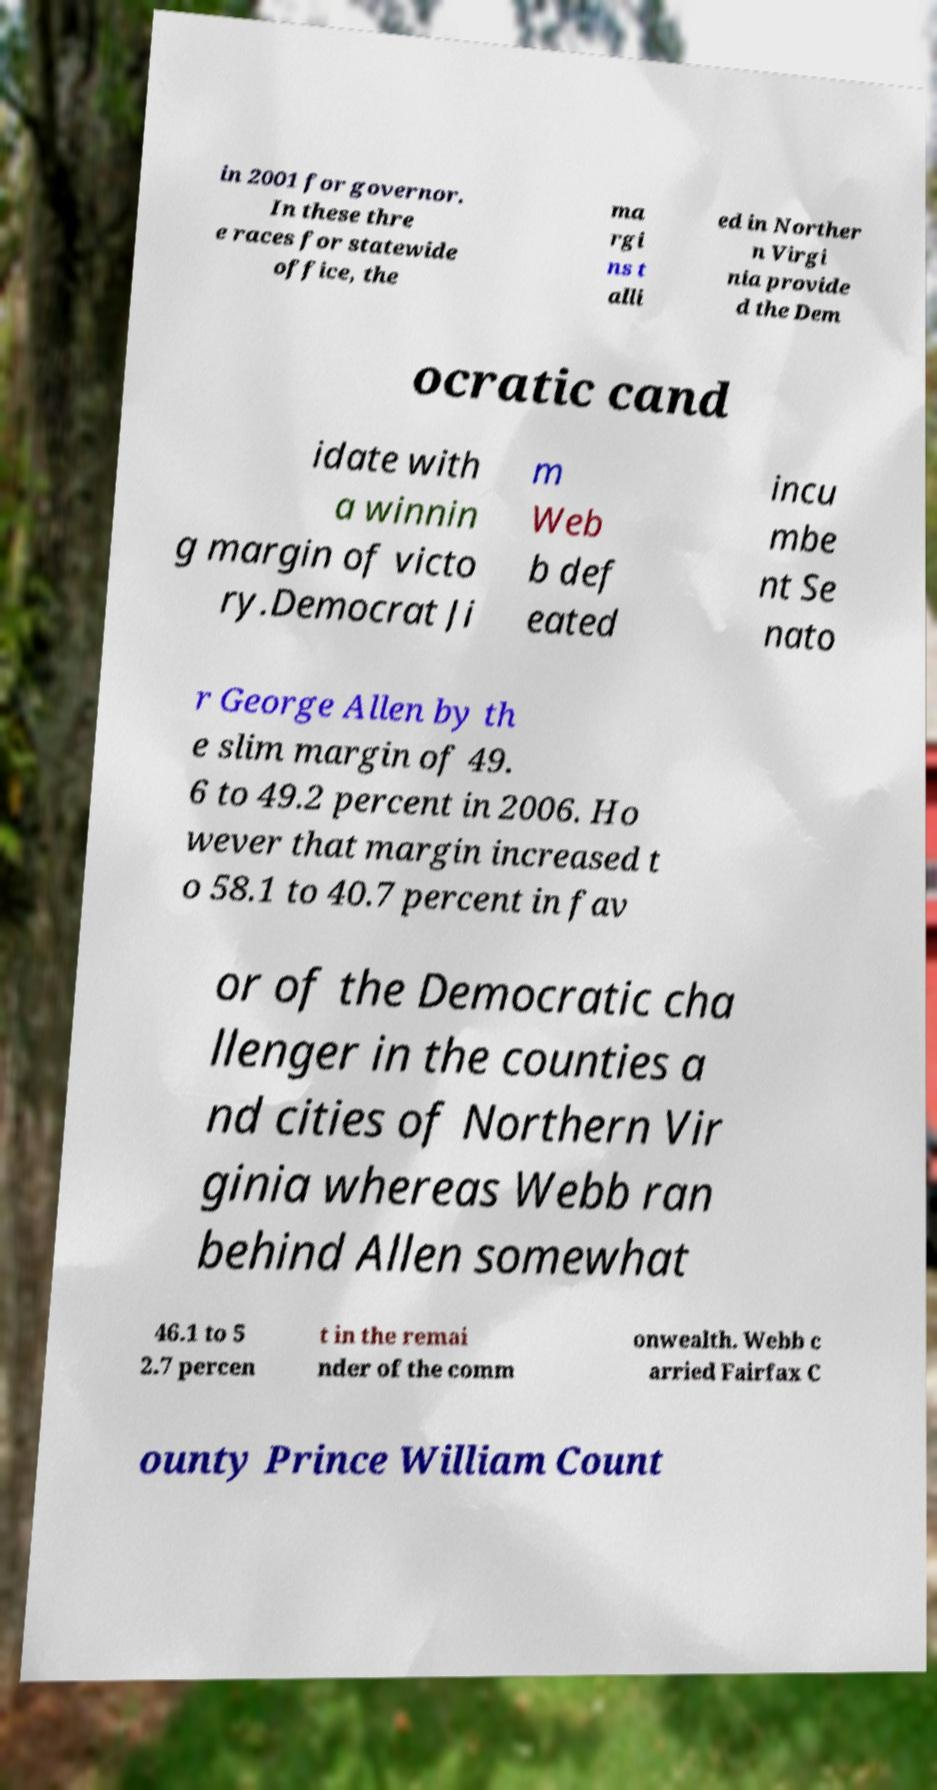Can you accurately transcribe the text from the provided image for me? in 2001 for governor. In these thre e races for statewide office, the ma rgi ns t alli ed in Norther n Virgi nia provide d the Dem ocratic cand idate with a winnin g margin of victo ry.Democrat Ji m Web b def eated incu mbe nt Se nato r George Allen by th e slim margin of 49. 6 to 49.2 percent in 2006. Ho wever that margin increased t o 58.1 to 40.7 percent in fav or of the Democratic cha llenger in the counties a nd cities of Northern Vir ginia whereas Webb ran behind Allen somewhat 46.1 to 5 2.7 percen t in the remai nder of the comm onwealth. Webb c arried Fairfax C ounty Prince William Count 